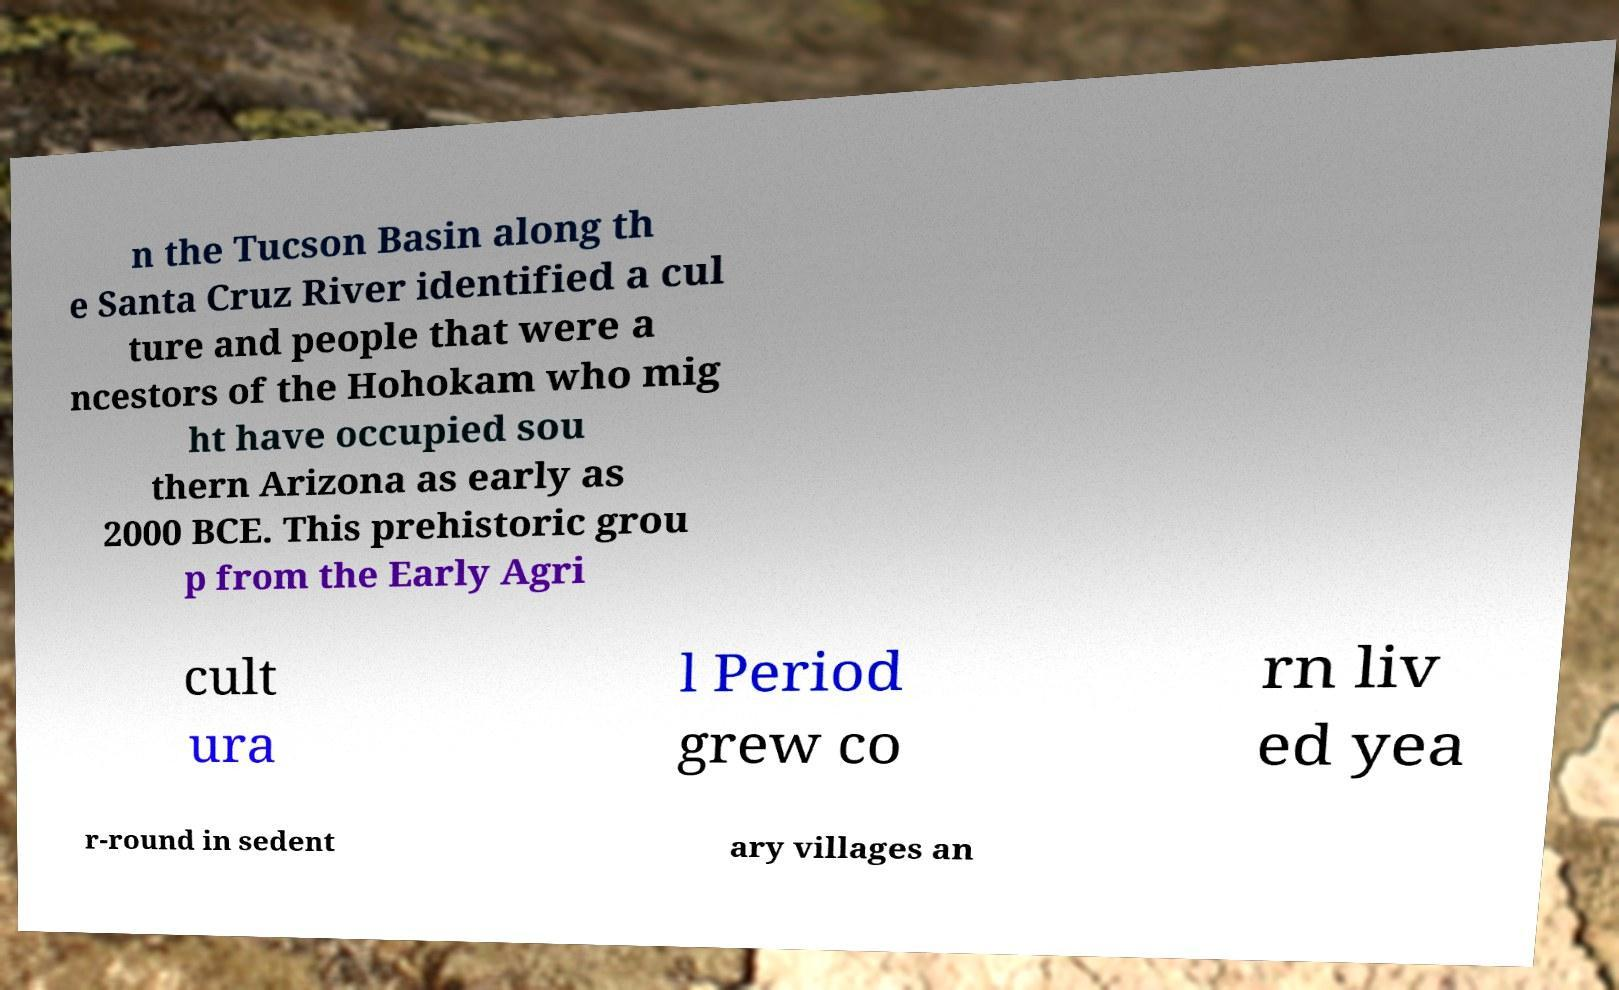Please read and relay the text visible in this image. What does it say? n the Tucson Basin along th e Santa Cruz River identified a cul ture and people that were a ncestors of the Hohokam who mig ht have occupied sou thern Arizona as early as 2000 BCE. This prehistoric grou p from the Early Agri cult ura l Period grew co rn liv ed yea r-round in sedent ary villages an 